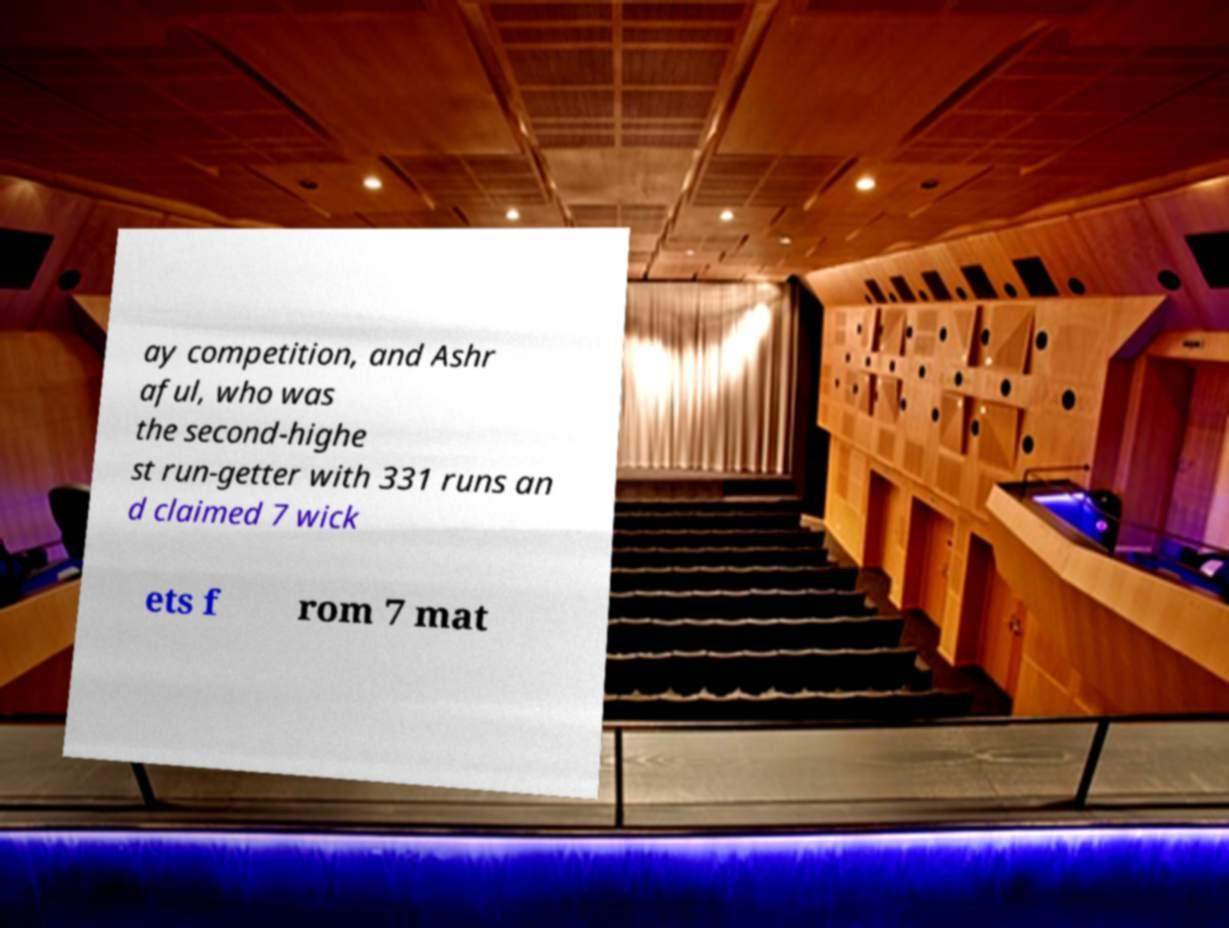For documentation purposes, I need the text within this image transcribed. Could you provide that? ay competition, and Ashr aful, who was the second-highe st run-getter with 331 runs an d claimed 7 wick ets f rom 7 mat 